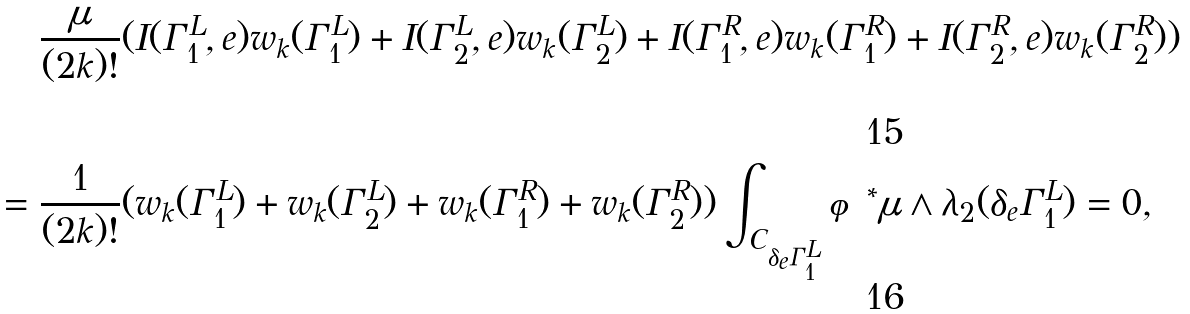<formula> <loc_0><loc_0><loc_500><loc_500>\frac { \mu } { ( 2 k ) ! } & ( I ( \Gamma ^ { L } _ { 1 } , e ) w _ { k } ( \Gamma ^ { L } _ { 1 } ) + I ( \Gamma ^ { L } _ { 2 } , e ) w _ { k } ( \Gamma ^ { L } _ { 2 } ) + I ( \Gamma ^ { R } _ { 1 } , e ) w _ { k } ( \Gamma ^ { R } _ { 1 } ) + I ( \Gamma ^ { R } _ { 2 } , e ) w _ { k } ( \Gamma ^ { R } _ { 2 } ) ) \\ = \frac { 1 } { ( 2 k ) ! } & ( w _ { k } ( \Gamma ^ { L } _ { 1 } ) + w _ { k } ( \Gamma ^ { L } _ { 2 } ) + w _ { k } ( \Gamma ^ { R } _ { 1 } ) + w _ { k } ( \Gamma ^ { R } _ { 2 } ) ) \int _ { C _ { \delta _ { e } \Gamma ^ { L } _ { 1 } } } \varphi ^ { * } \mu \wedge \lambda _ { 2 } ( \delta _ { e } \Gamma ^ { L } _ { 1 } ) = 0 ,</formula> 